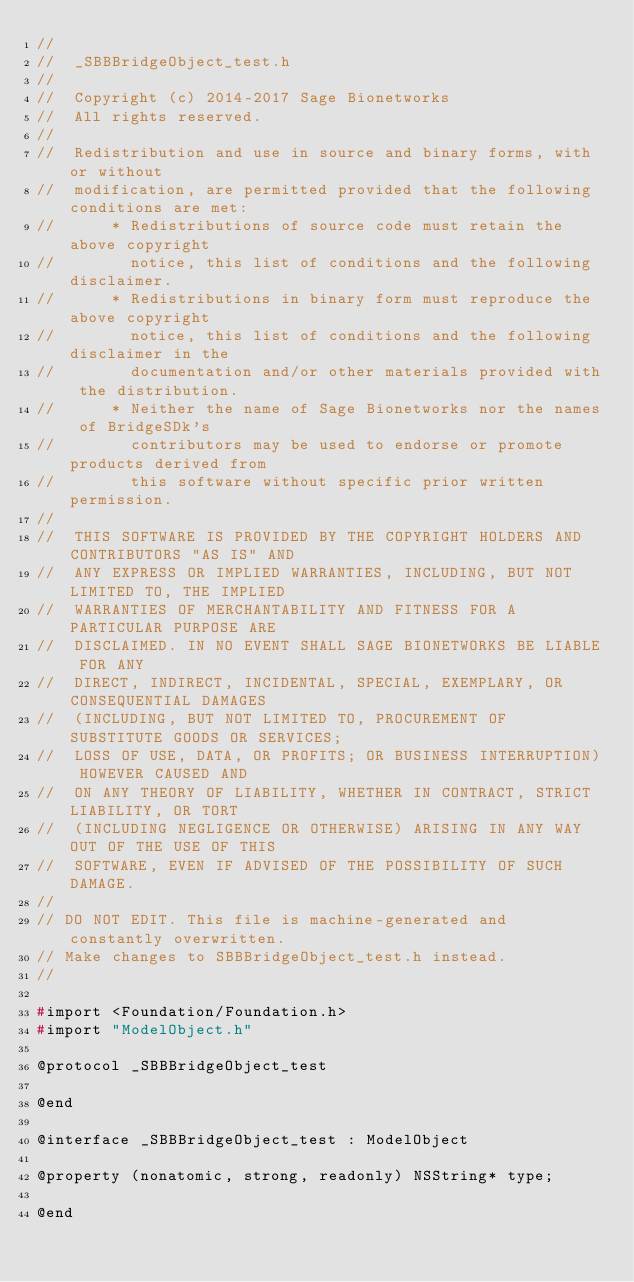Convert code to text. <code><loc_0><loc_0><loc_500><loc_500><_C_>//
//  _SBBBridgeObject_test.h
//
//	Copyright (c) 2014-2017 Sage Bionetworks
//	All rights reserved.
//
//	Redistribution and use in source and binary forms, with or without
//	modification, are permitted provided that the following conditions are met:
//	    * Redistributions of source code must retain the above copyright
//	      notice, this list of conditions and the following disclaimer.
//	    * Redistributions in binary form must reproduce the above copyright
//	      notice, this list of conditions and the following disclaimer in the
//	      documentation and/or other materials provided with the distribution.
//	    * Neither the name of Sage Bionetworks nor the names of BridgeSDk's
//		  contributors may be used to endorse or promote products derived from
//		  this software without specific prior written permission.
//
//	THIS SOFTWARE IS PROVIDED BY THE COPYRIGHT HOLDERS AND CONTRIBUTORS "AS IS" AND
//	ANY EXPRESS OR IMPLIED WARRANTIES, INCLUDING, BUT NOT LIMITED TO, THE IMPLIED
//	WARRANTIES OF MERCHANTABILITY AND FITNESS FOR A PARTICULAR PURPOSE ARE
//	DISCLAIMED. IN NO EVENT SHALL SAGE BIONETWORKS BE LIABLE FOR ANY
//	DIRECT, INDIRECT, INCIDENTAL, SPECIAL, EXEMPLARY, OR CONSEQUENTIAL DAMAGES
//	(INCLUDING, BUT NOT LIMITED TO, PROCUREMENT OF SUBSTITUTE GOODS OR SERVICES;
//	LOSS OF USE, DATA, OR PROFITS; OR BUSINESS INTERRUPTION) HOWEVER CAUSED AND
//	ON ANY THEORY OF LIABILITY, WHETHER IN CONTRACT, STRICT LIABILITY, OR TORT
//	(INCLUDING NEGLIGENCE OR OTHERWISE) ARISING IN ANY WAY OUT OF THE USE OF THIS
//	SOFTWARE, EVEN IF ADVISED OF THE POSSIBILITY OF SUCH DAMAGE.
//
// DO NOT EDIT. This file is machine-generated and constantly overwritten.
// Make changes to SBBBridgeObject_test.h instead.
//

#import <Foundation/Foundation.h>
#import "ModelObject.h"

@protocol _SBBBridgeObject_test

@end

@interface _SBBBridgeObject_test : ModelObject

@property (nonatomic, strong, readonly) NSString* type;

@end
</code> 